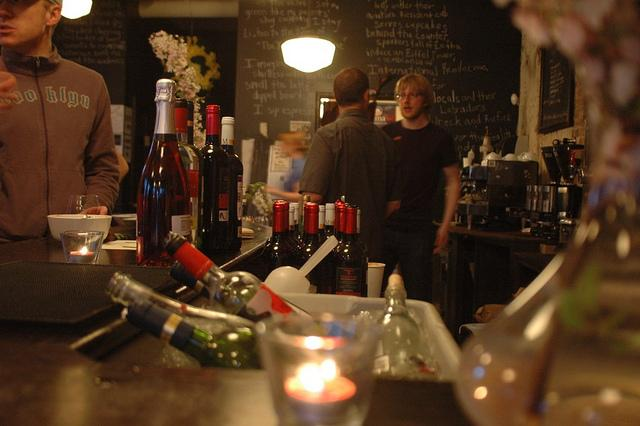Where are these people located? bar 